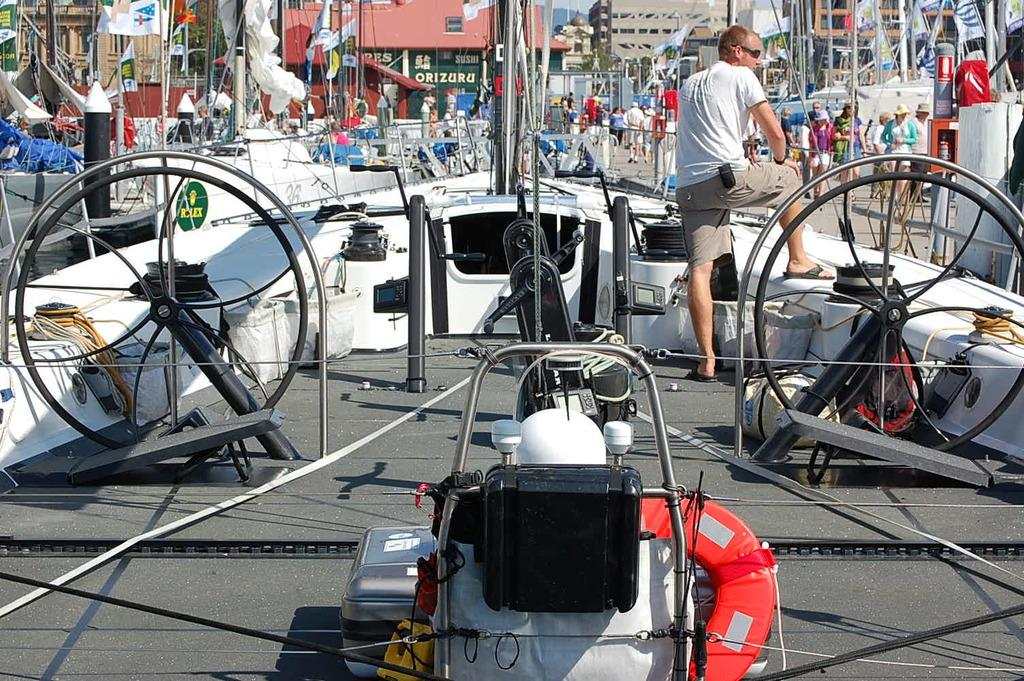What is the main subject of the image? The main subject of the image is a ship. Can you describe the man's position in the image? The man is standing on the right side of the ship. What is happening in the background of the image? There are people walking in the background of the image. What type of heart-shaped object can be seen in the image? There is no heart-shaped object present in the image. How many eggs are visible in the image? There are no eggs visible in the image. 